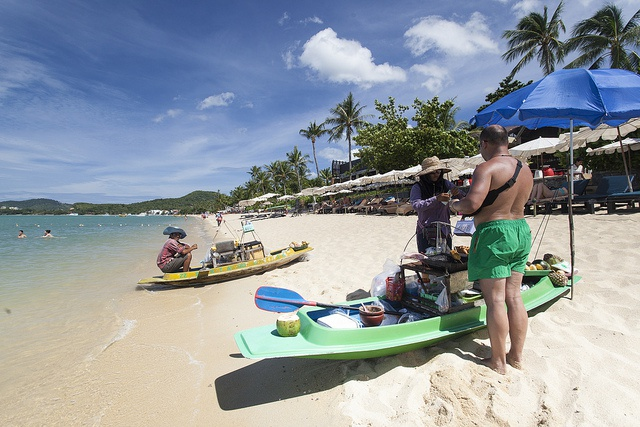Describe the objects in this image and their specific colors. I can see boat in gray, beige, lightgreen, and black tones, people in gray, darkgreen, and black tones, umbrella in gray, blue, darkblue, and lightblue tones, boat in gray, khaki, black, and darkgray tones, and people in gray, black, and darkgray tones in this image. 